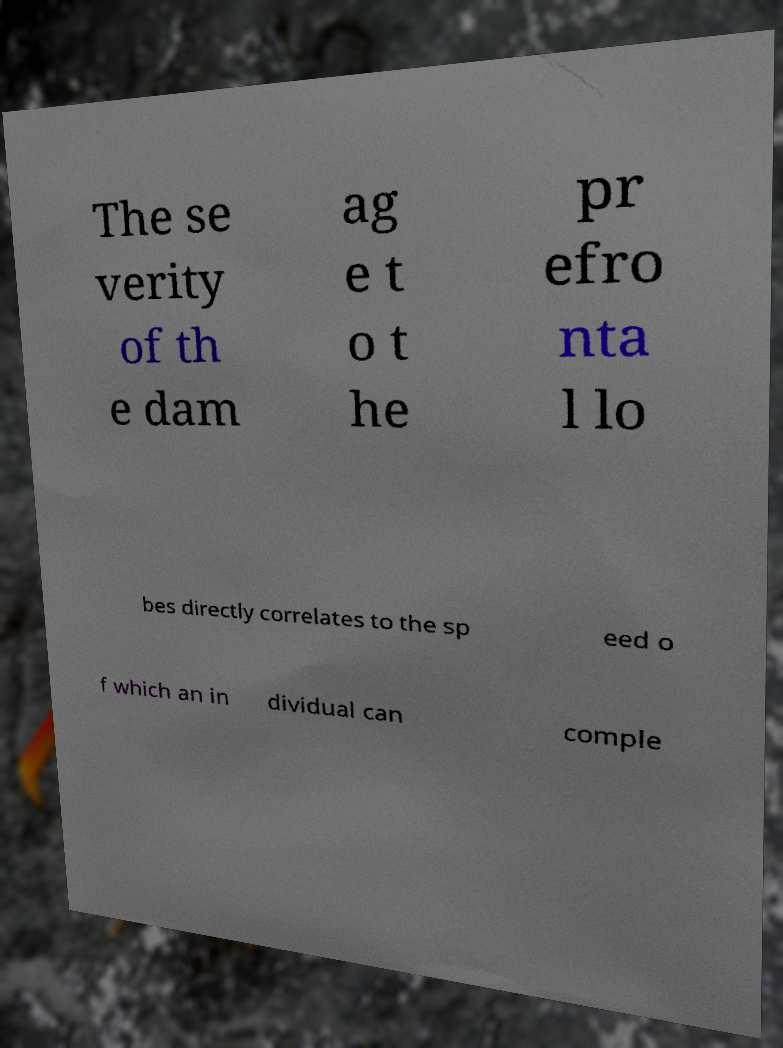What messages or text are displayed in this image? I need them in a readable, typed format. The se verity of th e dam ag e t o t he pr efro nta l lo bes directly correlates to the sp eed o f which an in dividual can comple 